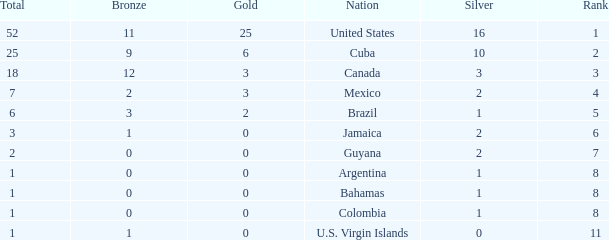What is the fewest number of silver medals a nation who ranked below 8 received? 0.0. 